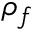<formula> <loc_0><loc_0><loc_500><loc_500>\rho _ { f }</formula> 